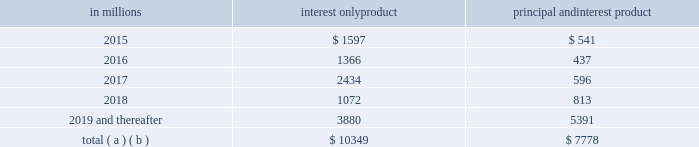On a regular basis our special asset committee closely monitors loans , primarily commercial loans , that are not included in the nonperforming or accruing past due categories and for which we are uncertain about the borrower 2019s ability to comply with existing repayment terms .
These loans totaled $ .2 billion at both december 31 , 2014 and december 31 , 2013 .
Home equity loan portfolio our home equity loan portfolio totaled $ 34.7 billion as of december 31 , 2014 , or 17% ( 17 % ) of the total loan portfolio .
Of that total , $ 20.4 billion , or 59% ( 59 % ) , was outstanding under primarily variable-rate home equity lines of credit and $ 14.3 billion , or 41% ( 41 % ) , consisted of closed-end home equity installment loans .
Approximately 3% ( 3 % ) of the home equity portfolio was on nonperforming status as of december 31 , 2014 .
As of december 31 , 2014 , we are in an originated first lien position for approximately 51% ( 51 % ) of the total portfolio and , where originated as a second lien , we currently hold or service the first lien position for approximately an additional 2% ( 2 % ) of the portfolio .
The remaining 47% ( 47 % ) of the portfolio was secured by second liens where we do not hold the first lien position .
The credit performance of the majority of the home equity portfolio where we are in , hold or service the first lien position , is superior to the portion of the portfolio where we hold the second lien position but do not hold the first lien .
Lien position information is generally based upon original ltv at the time of origination .
However , after origination pnc is not typically notified when a senior lien position that is not held by pnc is satisfied .
Therefore , information about the current lien status of junior lien loans is less readily available in cases where pnc does not also hold the senior lien .
Additionally , pnc is not typically notified when a junior lien position is added after origination of a pnc first lien .
This updated information for both junior and senior liens must be obtained from external sources , and therefore , pnc has contracted with an industry-leading third-party service provider to obtain updated loan , lien and collateral data that is aggregated from public and private sources .
We track borrower performance monthly , including obtaining original ltvs , updated fico scores at least quarterly , updated ltvs semi-annually , and other credit metrics at least quarterly , including the historical performance of any mortgage loans regardless of lien position that we do or do not hold .
This information is used for internal reporting and risk management .
For internal reporting and risk management we also segment the population into pools based on product type ( e.g. , home equity loans , brokered home equity loans , home equity lines of credit , brokered home equity lines of credit ) .
As part of our overall risk analysis and monitoring , we segment the home equity portfolio based upon the delinquency , modification status and bankruptcy status of these loans , as well as the delinquency , modification status and bankruptcy status of any mortgage loan with the same borrower ( regardless of whether it is a first lien senior to our second lien ) .
In establishing our alll for non-impaired loans , we primarily utilize a delinquency roll-rate methodology for pools of loans .
In accordance with accounting principles , under this methodology , we establish our allowance based upon incurred losses , not lifetime expected losses .
The roll-rate methodology estimates transition/roll of loan balances from one delinquency state ( e.g. , 30-59 days past due ) to another delinquency state ( e.g. , 60-89 days past due ) and ultimately to charge-off .
The roll through to charge-off is based on pnc 2019s actual loss experience for each type of pool .
Each of our home equity pools contains both first and second liens .
Our experience has been that the ratio of first to second lien loans has been consistent over time and the charge-off amounts for the pools , used to establish our allowance , include losses on both first and second liens loans .
Generally , our variable-rate home equity lines of credit have either a seven or ten year draw period , followed by a 20-year amortization term .
During the draw period , we have home equity lines of credit where borrowers pay either interest or principal and interest .
We view home equity lines of credit where borrowers are paying principal and interest under the draw period as less risky than those where the borrowers are paying interest only , as these borrowers have a demonstrated ability to make some level of principal and interest payments .
The risk associated with the borrower 2019s ability to satisfy the loan terms upon the draw period ending is considered in establishing our alll .
Based upon outstanding balances at december 31 , 2014 , the table presents the periods when home equity lines of credit draw periods are scheduled to end .
Table 36 : home equity lines of credit 2013 draw period end in millions interest only product principal and interest product .
( a ) includes all home equity lines of credit that mature in 2015 or later , including those with borrowers where we have terminated borrowing privileges .
( b ) includes approximately $ 154 million , $ 48 million , $ 57 million , $ 42 million and $ 564 million of home equity lines of credit with balloon payments , including those where we have terminated borrowing privileges , with draw periods scheduled to end in 2015 , 2016 , 2017 , 2018 and 2019 and thereafter , respectively .
76 the pnc financial services group , inc .
2013 form 10-k .
As of dec 31 , 2014 , how big is the total loan portfolio , in billions? 
Computations: ((34.7 / 17) * 100)
Answer: 204.11765. On a regular basis our special asset committee closely monitors loans , primarily commercial loans , that are not included in the nonperforming or accruing past due categories and for which we are uncertain about the borrower 2019s ability to comply with existing repayment terms .
These loans totaled $ .2 billion at both december 31 , 2014 and december 31 , 2013 .
Home equity loan portfolio our home equity loan portfolio totaled $ 34.7 billion as of december 31 , 2014 , or 17% ( 17 % ) of the total loan portfolio .
Of that total , $ 20.4 billion , or 59% ( 59 % ) , was outstanding under primarily variable-rate home equity lines of credit and $ 14.3 billion , or 41% ( 41 % ) , consisted of closed-end home equity installment loans .
Approximately 3% ( 3 % ) of the home equity portfolio was on nonperforming status as of december 31 , 2014 .
As of december 31 , 2014 , we are in an originated first lien position for approximately 51% ( 51 % ) of the total portfolio and , where originated as a second lien , we currently hold or service the first lien position for approximately an additional 2% ( 2 % ) of the portfolio .
The remaining 47% ( 47 % ) of the portfolio was secured by second liens where we do not hold the first lien position .
The credit performance of the majority of the home equity portfolio where we are in , hold or service the first lien position , is superior to the portion of the portfolio where we hold the second lien position but do not hold the first lien .
Lien position information is generally based upon original ltv at the time of origination .
However , after origination pnc is not typically notified when a senior lien position that is not held by pnc is satisfied .
Therefore , information about the current lien status of junior lien loans is less readily available in cases where pnc does not also hold the senior lien .
Additionally , pnc is not typically notified when a junior lien position is added after origination of a pnc first lien .
This updated information for both junior and senior liens must be obtained from external sources , and therefore , pnc has contracted with an industry-leading third-party service provider to obtain updated loan , lien and collateral data that is aggregated from public and private sources .
We track borrower performance monthly , including obtaining original ltvs , updated fico scores at least quarterly , updated ltvs semi-annually , and other credit metrics at least quarterly , including the historical performance of any mortgage loans regardless of lien position that we do or do not hold .
This information is used for internal reporting and risk management .
For internal reporting and risk management we also segment the population into pools based on product type ( e.g. , home equity loans , brokered home equity loans , home equity lines of credit , brokered home equity lines of credit ) .
As part of our overall risk analysis and monitoring , we segment the home equity portfolio based upon the delinquency , modification status and bankruptcy status of these loans , as well as the delinquency , modification status and bankruptcy status of any mortgage loan with the same borrower ( regardless of whether it is a first lien senior to our second lien ) .
In establishing our alll for non-impaired loans , we primarily utilize a delinquency roll-rate methodology for pools of loans .
In accordance with accounting principles , under this methodology , we establish our allowance based upon incurred losses , not lifetime expected losses .
The roll-rate methodology estimates transition/roll of loan balances from one delinquency state ( e.g. , 30-59 days past due ) to another delinquency state ( e.g. , 60-89 days past due ) and ultimately to charge-off .
The roll through to charge-off is based on pnc 2019s actual loss experience for each type of pool .
Each of our home equity pools contains both first and second liens .
Our experience has been that the ratio of first to second lien loans has been consistent over time and the charge-off amounts for the pools , used to establish our allowance , include losses on both first and second liens loans .
Generally , our variable-rate home equity lines of credit have either a seven or ten year draw period , followed by a 20-year amortization term .
During the draw period , we have home equity lines of credit where borrowers pay either interest or principal and interest .
We view home equity lines of credit where borrowers are paying principal and interest under the draw period as less risky than those where the borrowers are paying interest only , as these borrowers have a demonstrated ability to make some level of principal and interest payments .
The risk associated with the borrower 2019s ability to satisfy the loan terms upon the draw period ending is considered in establishing our alll .
Based upon outstanding balances at december 31 , 2014 , the table presents the periods when home equity lines of credit draw periods are scheduled to end .
Table 36 : home equity lines of credit 2013 draw period end in millions interest only product principal and interest product .
( a ) includes all home equity lines of credit that mature in 2015 or later , including those with borrowers where we have terminated borrowing privileges .
( b ) includes approximately $ 154 million , $ 48 million , $ 57 million , $ 42 million and $ 564 million of home equity lines of credit with balloon payments , including those where we have terminated borrowing privileges , with draw periods scheduled to end in 2015 , 2016 , 2017 , 2018 and 2019 and thereafter , respectively .
76 the pnc financial services group , inc .
2013 form 10-k .
For total interest only home equity lines of credit , what percentage of the total includes home equity lines of credit with balloon payments , including those where we have terminated borrowing privileges , with draw periods scheduled to end in 2015? 
Computations: (154 / 10349)
Answer: 0.01488. 